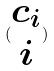<formula> <loc_0><loc_0><loc_500><loc_500>( \begin{matrix} c _ { i } \\ i \end{matrix} )</formula> 